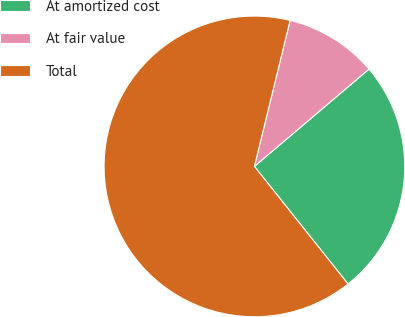<chart> <loc_0><loc_0><loc_500><loc_500><pie_chart><fcel>At amortized cost<fcel>At fair value<fcel>Total<nl><fcel>25.5%<fcel>9.98%<fcel>64.52%<nl></chart> 